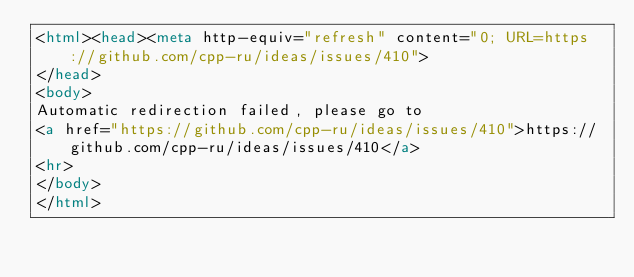<code> <loc_0><loc_0><loc_500><loc_500><_HTML_><html><head><meta http-equiv="refresh" content="0; URL=https://github.com/cpp-ru/ideas/issues/410">
</head>
<body>
Automatic redirection failed, please go to
<a href="https://github.com/cpp-ru/ideas/issues/410">https://github.com/cpp-ru/ideas/issues/410</a>
<hr>
</body>
</html>
</code> 